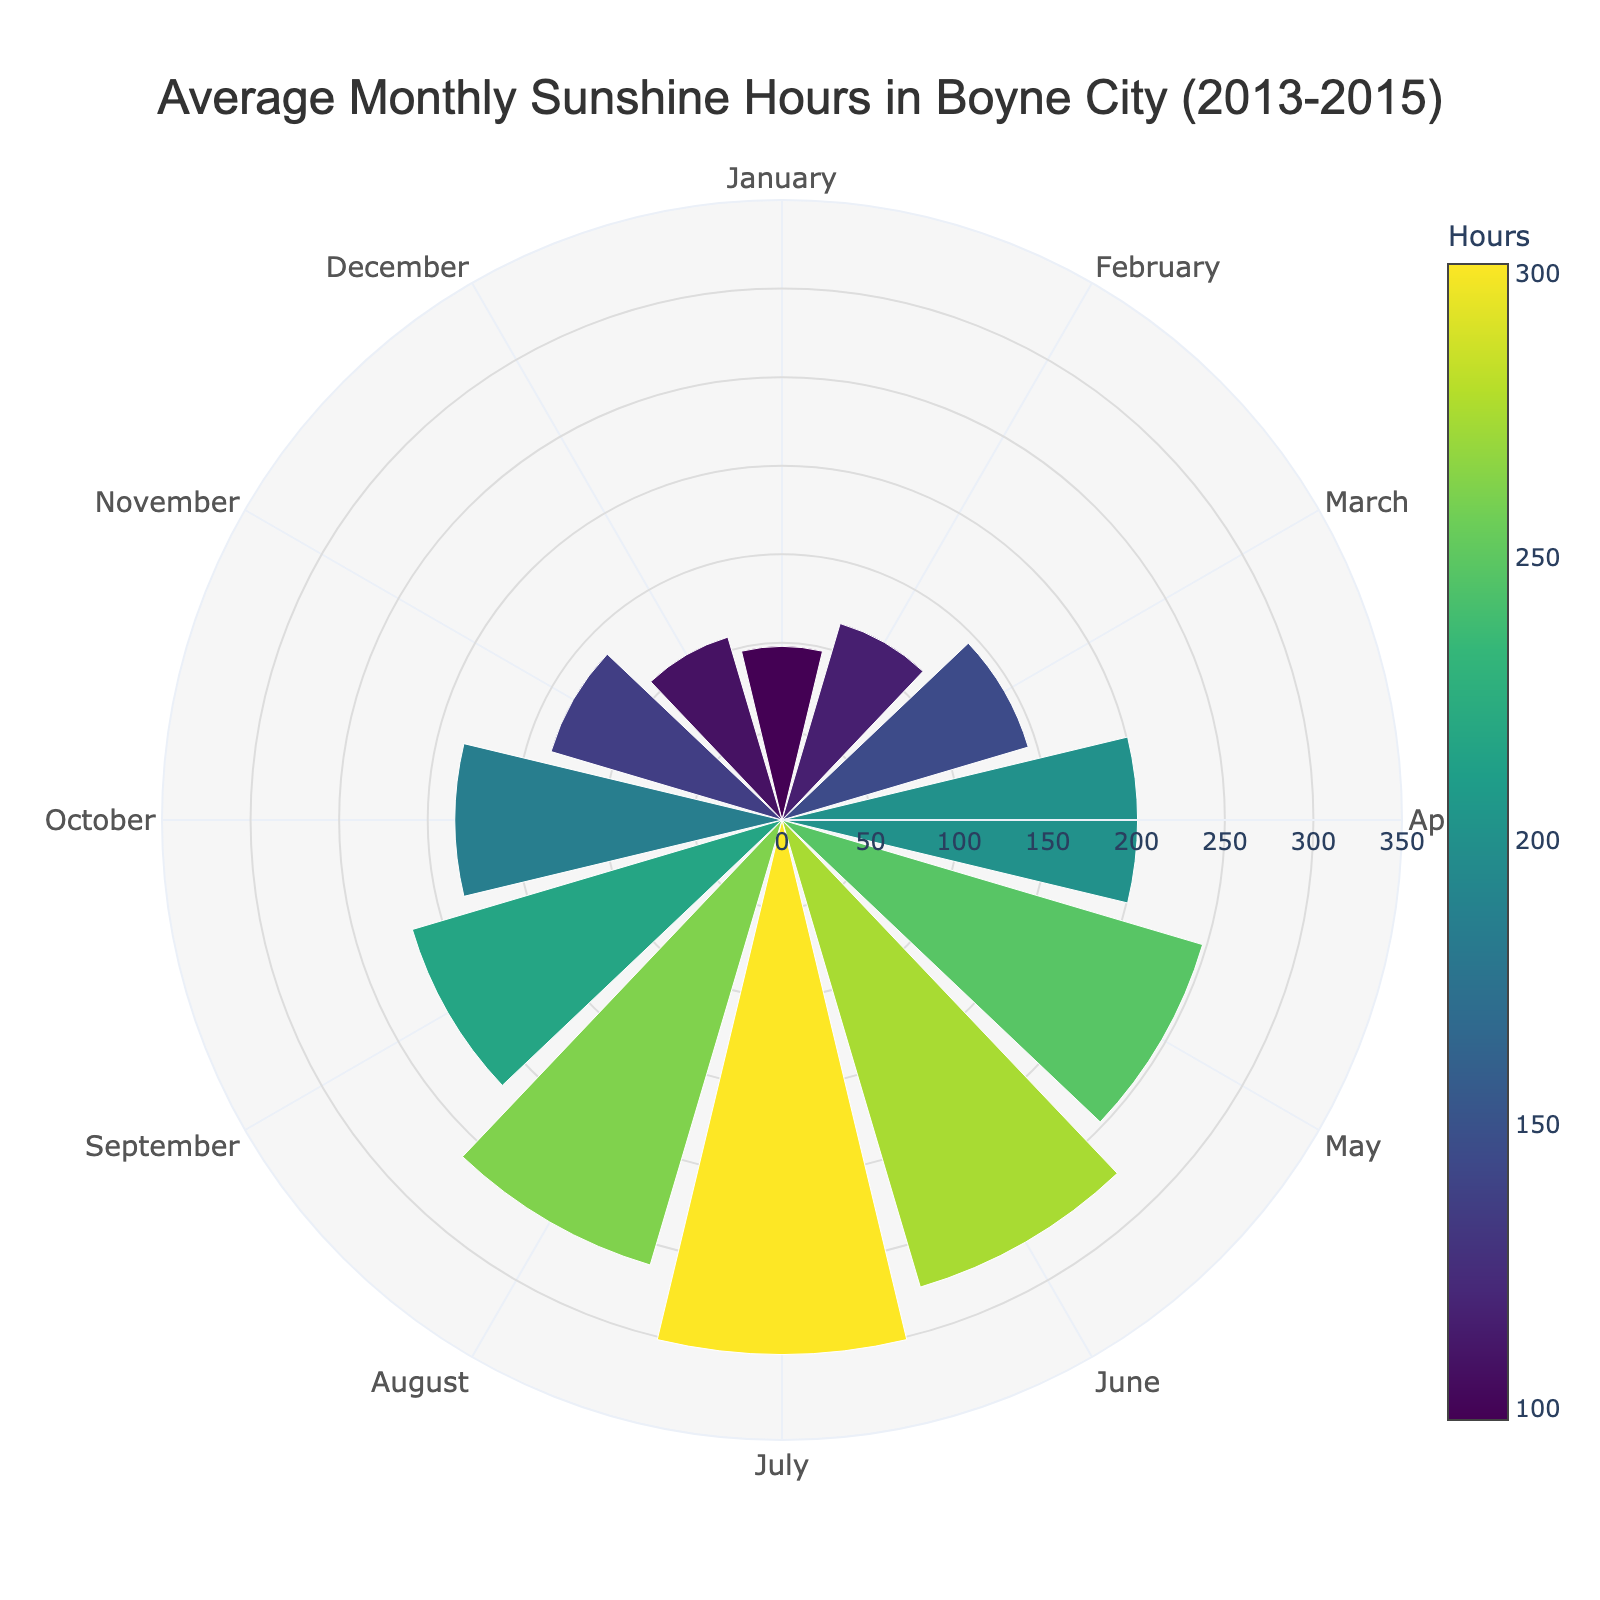What is the title of the figure? The title is usually displayed prominently at the top of the chart. By observing it, we can get an overview of what the chart is depicting.
Answer: Average Monthly Sunshine Hours in Boyne City (2013-2015) Which month has the highest average hours of sunshine? By examining the length of the bars in the polar chart, the longest bar represents the month with the highest average hours of sunshine.
Answer: July Which two months have the lowest average hours of sunshine? By analyzing the shortest bars in the polar chart, we can identify the two lowest points for monthly average sunshine hours.
Answer: January and December What is the average number of hours of sunshine in April? Look for the bar labeled 'April' on the polar area chart and read the value associated with it.
Answer: 200 Compare the average hours of sunshine in June and September. Which month has more sunshine? Identify the positions of June and September bars on the chart and compare their lengths. The longer bar indicates the month with more sunshine.
Answer: June What is the average number of hours of sunshine in February? Locate the bar representing February on the polar chart and note the value.
Answer: 116 What is the difference in average sunshine hours between April and November? Find the values of the bars for April and November, then subtract the November value from the April value.
Answer: 200 - 136 = 64 Considering the polar chart data, is the pattern of sunshine hours increasing or decreasing from January to December? Observe the trend in bar lengths from January to December. An increasing, decreasing, or inconsistent pattern will help answer this.
Answer: Increasing from January to July, then decreasing to December What is the color scale used in the chart to represent different hours of sunshine? Examine the color gradient displayed alongside the bars, as this indicates the color scale used for representing the data values.
Answer: Viridis How does the average sunshine in August compare to that in May? Identify the bars for May and August and compare their lengths to see which one is longer, indicating more sunshine hours.
Answer: May has less sunshine hours than August 